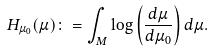Convert formula to latex. <formula><loc_0><loc_0><loc_500><loc_500>H _ { \mu _ { 0 } } ( \mu ) \colon = \int _ { M } \log \left ( \frac { d \mu } { d \mu _ { 0 } } \right ) d \mu .</formula> 